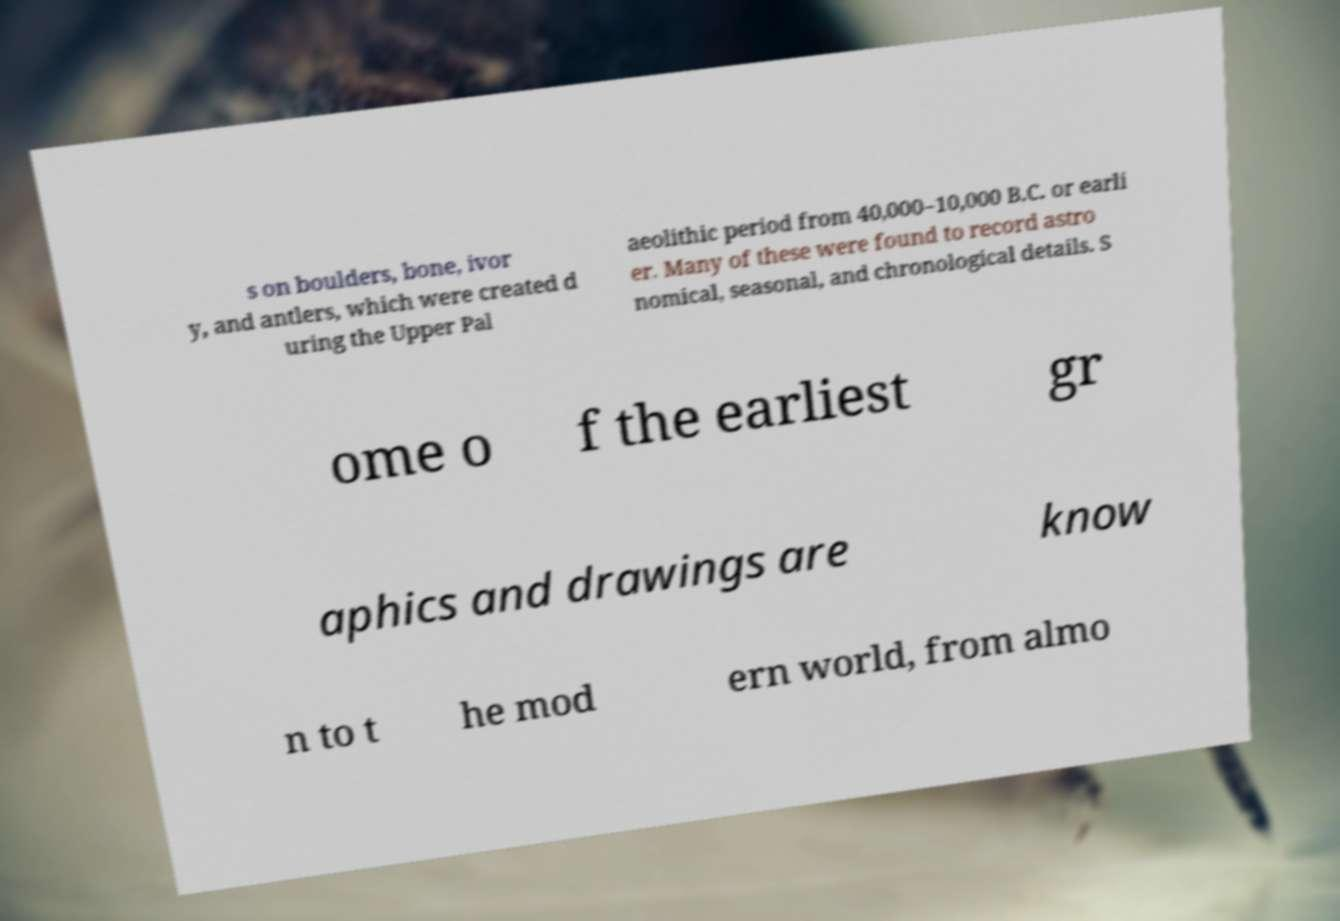Can you read and provide the text displayed in the image?This photo seems to have some interesting text. Can you extract and type it out for me? s on boulders, bone, ivor y, and antlers, which were created d uring the Upper Pal aeolithic period from 40,000–10,000 B.C. or earli er. Many of these were found to record astro nomical, seasonal, and chronological details. S ome o f the earliest gr aphics and drawings are know n to t he mod ern world, from almo 